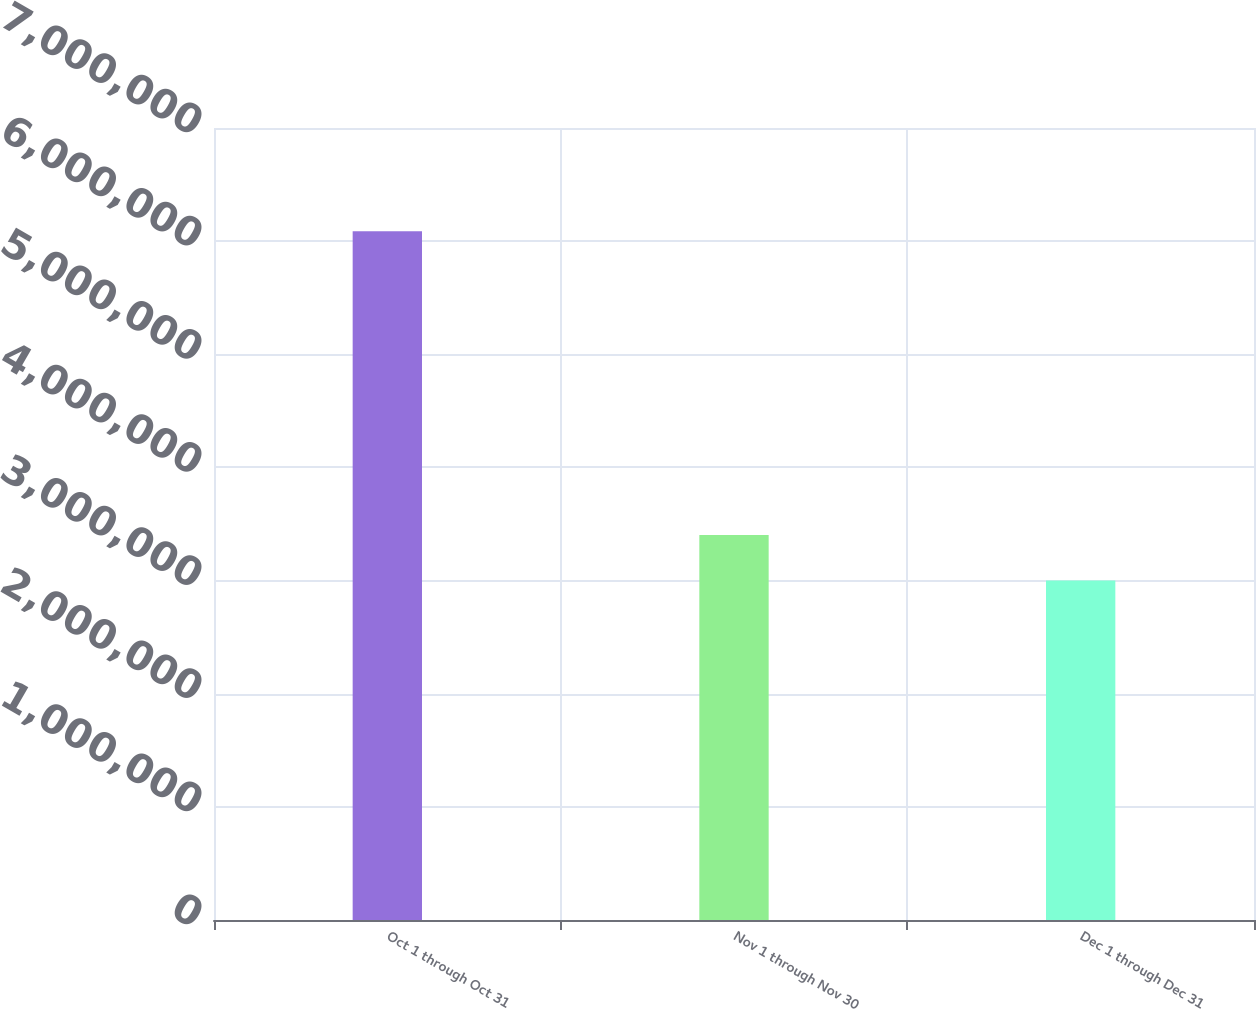Convert chart to OTSL. <chart><loc_0><loc_0><loc_500><loc_500><bar_chart><fcel>Oct 1 through Oct 31<fcel>Nov 1 through Nov 30<fcel>Dec 1 through Dec 31<nl><fcel>6.08773e+06<fcel>3.40219e+06<fcel>3.00072e+06<nl></chart> 